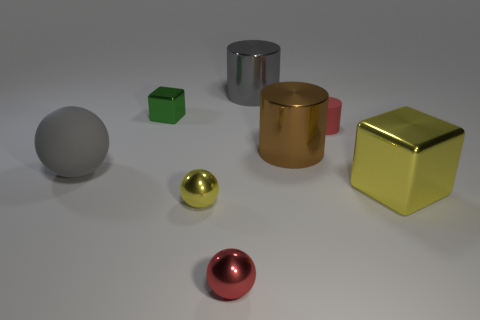Are there any tiny green metal blocks behind the green cube?
Offer a terse response. No. The small object that is both behind the tiny yellow sphere and on the left side of the brown metallic object is made of what material?
Give a very brief answer. Metal. Is the material of the small red cylinder in front of the tiny green metal thing the same as the brown object?
Your response must be concise. No. What is the large ball made of?
Your answer should be compact. Rubber. What is the size of the metal cylinder that is in front of the small cylinder?
Your answer should be very brief. Large. Are there any other things of the same color as the tiny matte object?
Your answer should be compact. Yes. Are there any tiny green metal objects behind the metal cylinder behind the tiny red object behind the large matte sphere?
Make the answer very short. No. Do the metal cylinder that is in front of the red matte object and the rubber cylinder have the same color?
Your answer should be compact. No. What number of cubes are yellow things or large red things?
Provide a short and direct response. 1. There is a small metallic thing behind the cube in front of the green thing; what is its shape?
Make the answer very short. Cube. 